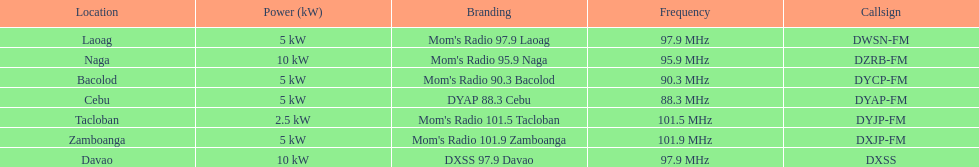What are the frequencies for radios of dyap-fm? 97.9 MHz, 95.9 MHz, 90.3 MHz, 88.3 MHz, 101.5 MHz, 101.9 MHz, 97.9 MHz. What is the lowest frequency? 88.3 MHz. Can you give me this table as a dict? {'header': ['Location', 'Power (kW)', 'Branding', 'Frequency', 'Callsign'], 'rows': [['Laoag', '5\xa0kW', "Mom's Radio 97.9 Laoag", '97.9\xa0MHz', 'DWSN-FM'], ['Naga', '10\xa0kW', "Mom's Radio 95.9 Naga", '95.9\xa0MHz', 'DZRB-FM'], ['Bacolod', '5\xa0kW', "Mom's Radio 90.3 Bacolod", '90.3\xa0MHz', 'DYCP-FM'], ['Cebu', '5\xa0kW', 'DYAP 88.3 Cebu', '88.3\xa0MHz', 'DYAP-FM'], ['Tacloban', '2.5\xa0kW', "Mom's Radio 101.5 Tacloban", '101.5\xa0MHz', 'DYJP-FM'], ['Zamboanga', '5\xa0kW', "Mom's Radio 101.9 Zamboanga", '101.9\xa0MHz', 'DXJP-FM'], ['Davao', '10\xa0kW', 'DXSS 97.9 Davao', '97.9\xa0MHz', 'DXSS']]} Which radio has this frequency? DYAP 88.3 Cebu. 